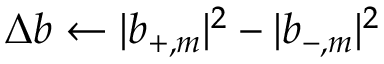Convert formula to latex. <formula><loc_0><loc_0><loc_500><loc_500>\Delta b \gets | b _ { + , m } | ^ { 2 } - | b _ { - , m } | ^ { 2 }</formula> 